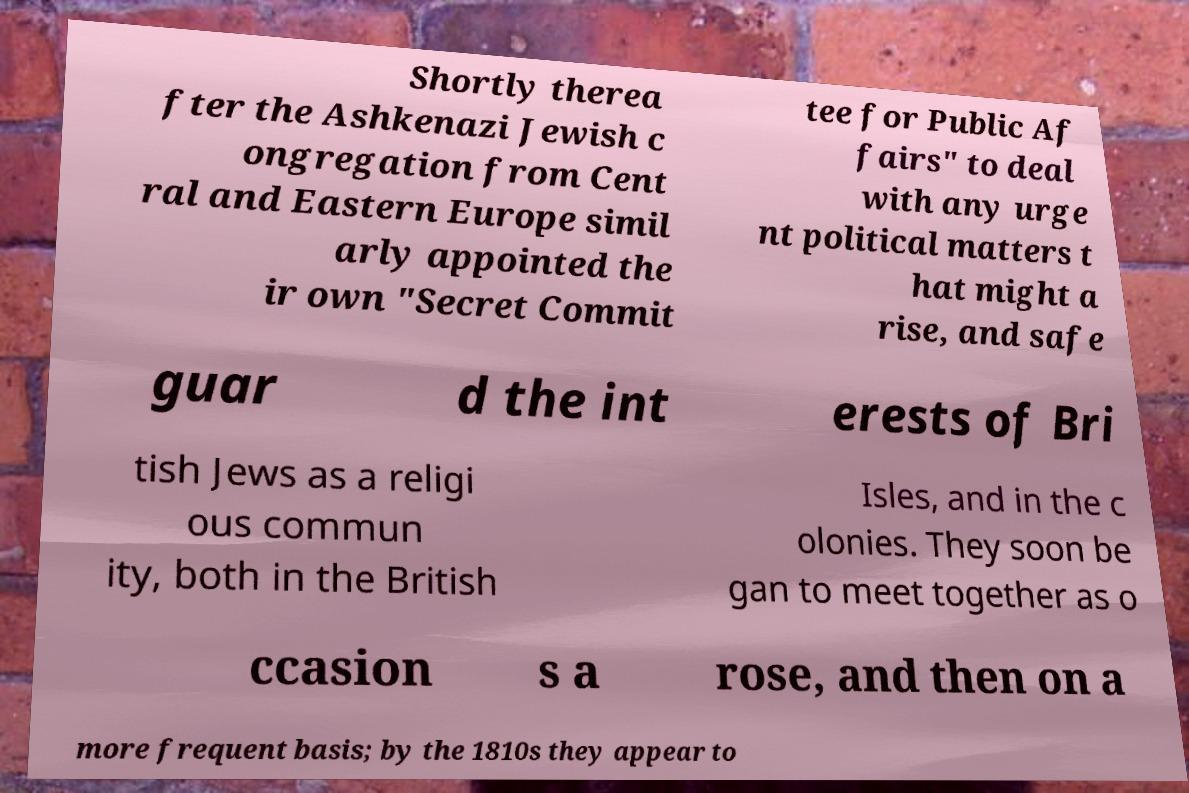Please read and relay the text visible in this image. What does it say? Shortly therea fter the Ashkenazi Jewish c ongregation from Cent ral and Eastern Europe simil arly appointed the ir own "Secret Commit tee for Public Af fairs" to deal with any urge nt political matters t hat might a rise, and safe guar d the int erests of Bri tish Jews as a religi ous commun ity, both in the British Isles, and in the c olonies. They soon be gan to meet together as o ccasion s a rose, and then on a more frequent basis; by the 1810s they appear to 